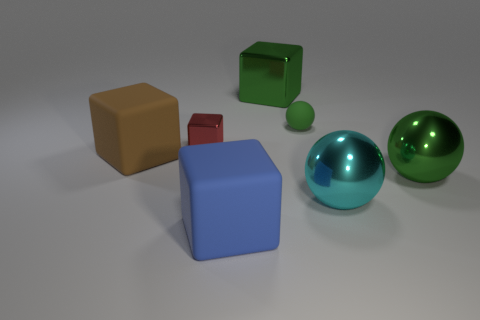How many other objects are there of the same material as the blue object?
Offer a terse response. 2. There is a metal ball right of the cyan sphere; does it have the same color as the small sphere?
Your answer should be compact. Yes. Are there more large metallic objects in front of the large green block than matte spheres that are to the right of the tiny red object?
Ensure brevity in your answer.  Yes. Are there more tiny red objects than purple metal spheres?
Provide a short and direct response. Yes. There is a ball that is both in front of the large brown object and on the left side of the big green metallic ball; how big is it?
Provide a short and direct response. Large. What is the shape of the red object?
Offer a terse response. Cube. Are there more large cyan things to the left of the big green metal ball than small cyan matte objects?
Offer a terse response. Yes. What is the shape of the green metal object behind the large green object in front of the big rubber block behind the big green ball?
Make the answer very short. Cube. There is a object that is on the right side of the cyan metallic ball; does it have the same size as the cyan metallic ball?
Offer a very short reply. Yes. There is a matte object that is both behind the large cyan metallic thing and on the left side of the small green thing; what shape is it?
Give a very brief answer. Cube. 